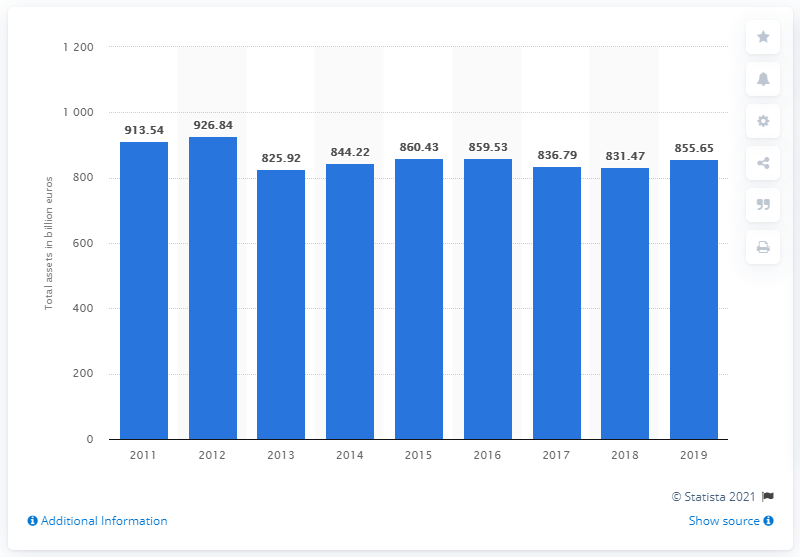Outline some significant characteristics in this image. In 2019, the total assets of UniCredit were 855.65. 